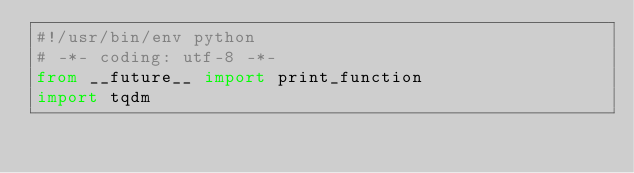Convert code to text. <code><loc_0><loc_0><loc_500><loc_500><_Python_>#!/usr/bin/env python
# -*- coding: utf-8 -*-
from __future__ import print_function
import tqdm</code> 